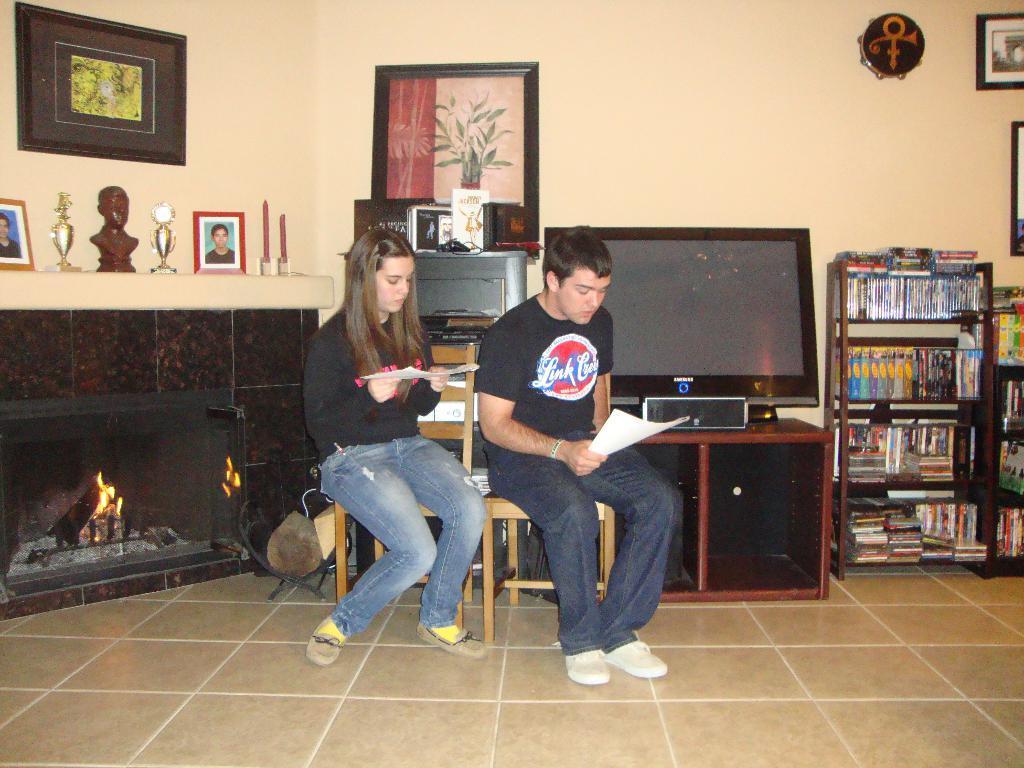How would you summarize this image in a sentence or two? There is a man woman sitting beside in chairs behind Tv and book shelf. 